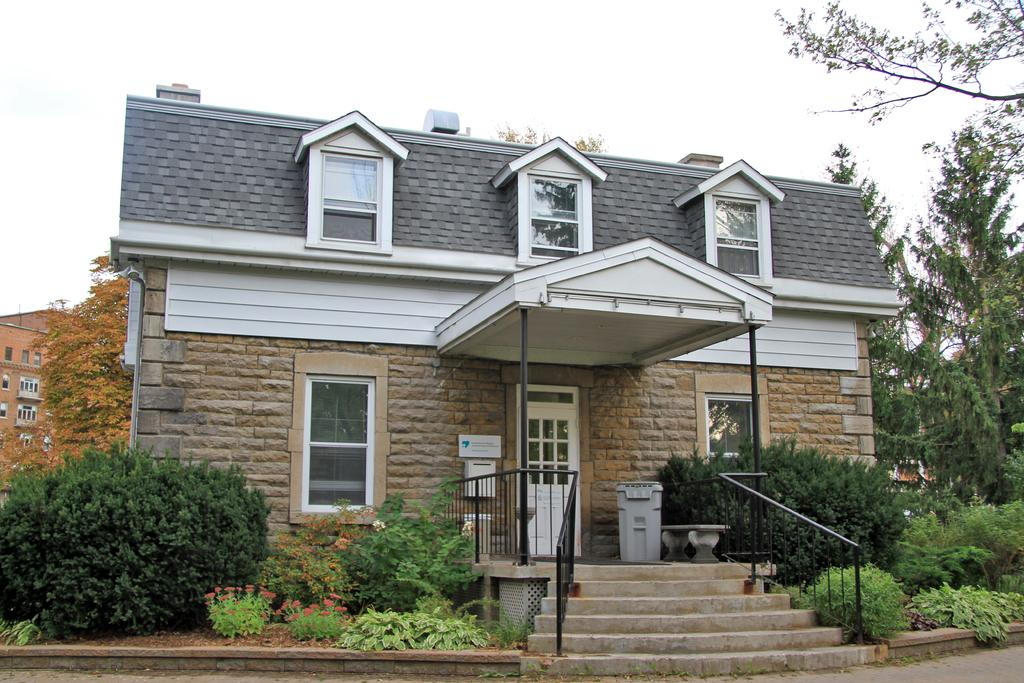What type of structures can be seen in the image? There are houses in the image. What architectural features are present in the houses? There are windows, doors, and a staircase with handrails in the image. What objects are present in the outdoor setting? There is a dustbin, a bench, plants, flowers, and trees in the image. What is visible in the sky? The sky is visible in the image. How many apples are hanging from the trees in the image? There are no apples present in the image; only flowers and trees can be seen. What type of quartz can be found in the image? There is no quartz present in the image. 